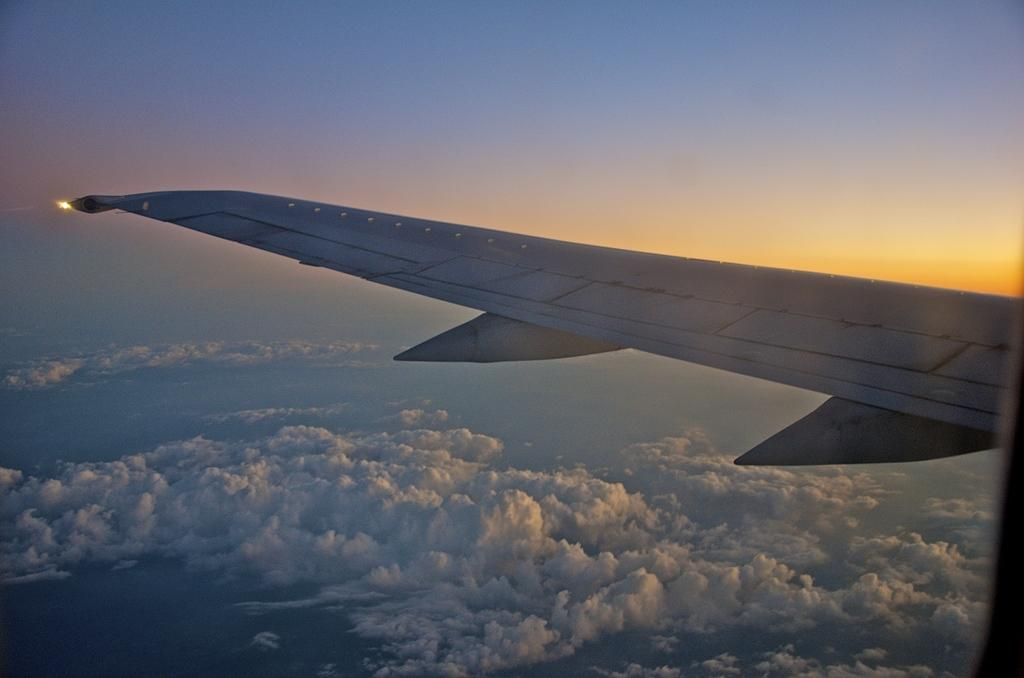What is the main subject of the image? The main subject of the image is a wing of a plane. What can be seen in the background of the image? There are clouds and the sky visible in the background of the image. What type of nut is being used to whistle in the image? There is no nut or whistling activity present in the image; it features a wing of a plane and clouds in the sky. 